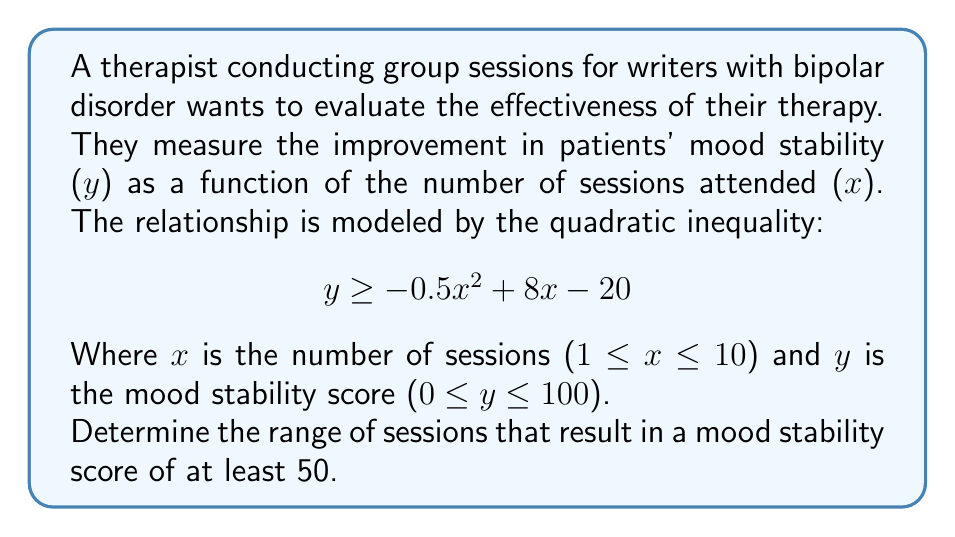Can you answer this question? 1) To find the range of sessions, we need to solve the inequality:

   $$50 \leq -0.5x^2 + 8x - 20$$

2) Rearrange the inequality:

   $$0 \leq -0.5x^2 + 8x - 70$$

3) Multiply everything by -2 (flipping the inequality sign):

   $$0 \geq x^2 - 16x + 140$$

4) This is a quadratic inequality. To solve it, we first find the roots of the quadratic equation:

   $$x^2 - 16x + 140 = 0$$

5) Using the quadratic formula, $x = \frac{-b \pm \sqrt{b^2 - 4ac}}{2a}$, we get:

   $$x = \frac{16 \pm \sqrt{256 - 560}}{2} = \frac{16 \pm \sqrt{-304}}{2}$$

6) Since the discriminant is negative, there are no real roots. This means the parabola never crosses the x-axis.

7) The coefficient of $x^2$ is positive, so the parabola opens upward. This means the inequality $0 \geq x^2 - 16x + 140$ is satisfied for all real x values.

8) However, we are constrained by the domain 1 ≤ x ≤ 10 (number of sessions).

Therefore, the mood stability score is at least 50 for all sessions from 1 to 10, inclusive.
Answer: [1, 10] 